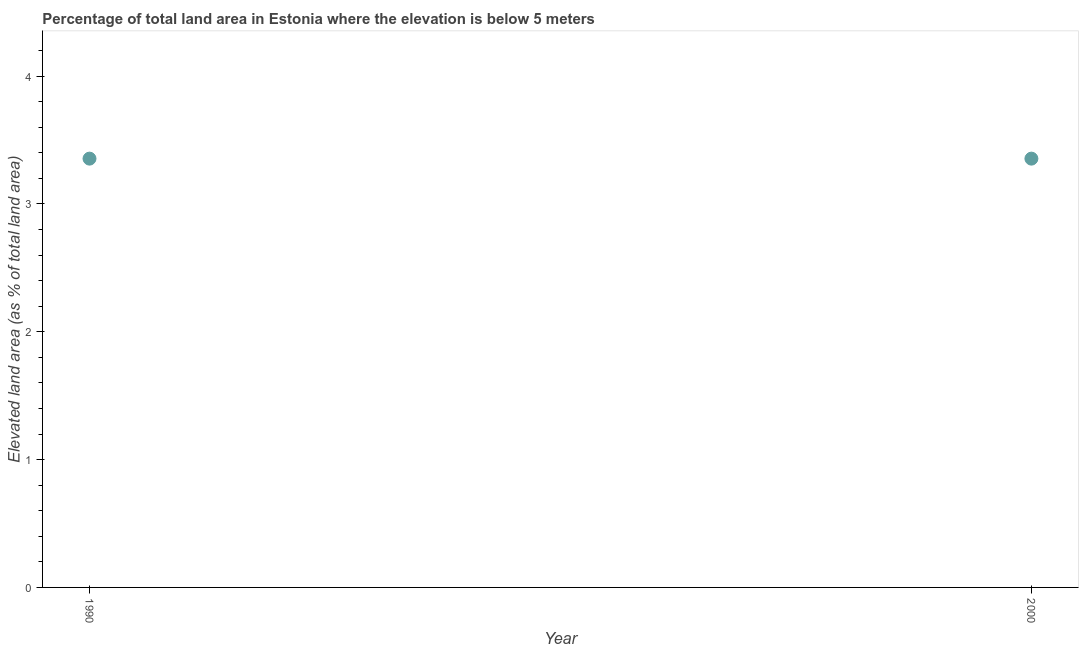What is the total elevated land area in 1990?
Offer a terse response. 3.35. Across all years, what is the maximum total elevated land area?
Your answer should be compact. 3.35. Across all years, what is the minimum total elevated land area?
Provide a succinct answer. 3.35. In which year was the total elevated land area maximum?
Give a very brief answer. 1990. What is the sum of the total elevated land area?
Your response must be concise. 6.71. What is the average total elevated land area per year?
Offer a very short reply. 3.35. What is the median total elevated land area?
Give a very brief answer. 3.35. In how many years, is the total elevated land area greater than 1.2 %?
Provide a short and direct response. 2. Do a majority of the years between 2000 and 1990 (inclusive) have total elevated land area greater than 1.8 %?
Give a very brief answer. No. What is the ratio of the total elevated land area in 1990 to that in 2000?
Give a very brief answer. 1. What is the difference between two consecutive major ticks on the Y-axis?
Your response must be concise. 1. Are the values on the major ticks of Y-axis written in scientific E-notation?
Make the answer very short. No. What is the title of the graph?
Keep it short and to the point. Percentage of total land area in Estonia where the elevation is below 5 meters. What is the label or title of the Y-axis?
Offer a very short reply. Elevated land area (as % of total land area). What is the Elevated land area (as % of total land area) in 1990?
Your response must be concise. 3.35. What is the Elevated land area (as % of total land area) in 2000?
Make the answer very short. 3.35. 